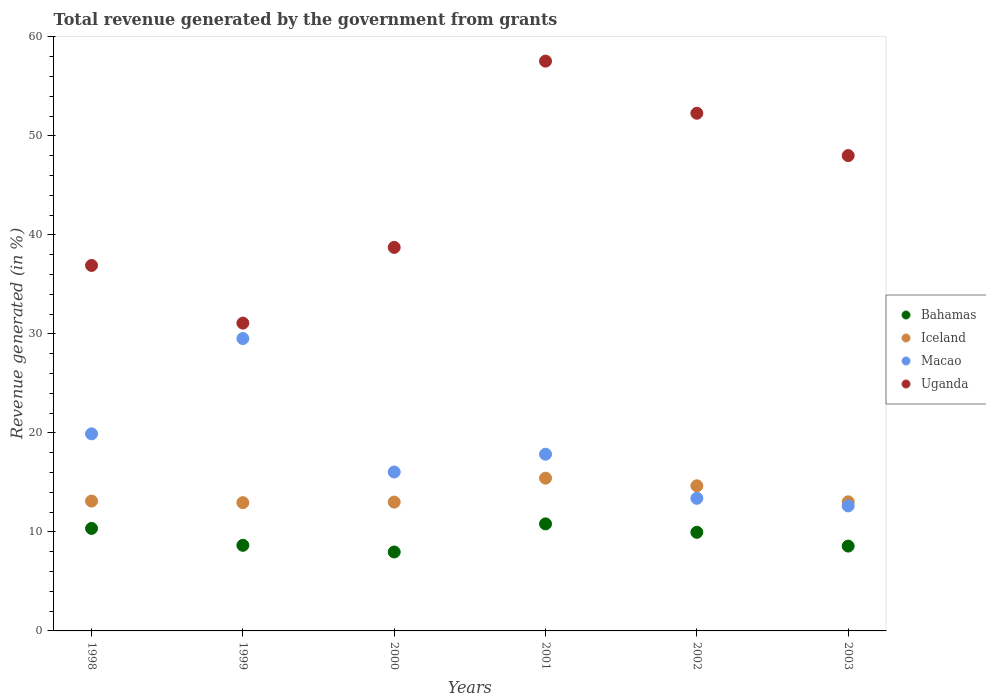How many different coloured dotlines are there?
Keep it short and to the point. 4. What is the total revenue generated in Bahamas in 1999?
Give a very brief answer. 8.64. Across all years, what is the maximum total revenue generated in Iceland?
Ensure brevity in your answer.  15.43. Across all years, what is the minimum total revenue generated in Iceland?
Keep it short and to the point. 12.95. In which year was the total revenue generated in Bahamas maximum?
Your answer should be very brief. 2001. In which year was the total revenue generated in Iceland minimum?
Your response must be concise. 1999. What is the total total revenue generated in Uganda in the graph?
Ensure brevity in your answer.  264.56. What is the difference between the total revenue generated in Iceland in 1999 and that in 2002?
Ensure brevity in your answer.  -1.7. What is the difference between the total revenue generated in Bahamas in 1998 and the total revenue generated in Macao in 2003?
Give a very brief answer. -2.27. What is the average total revenue generated in Iceland per year?
Offer a very short reply. 13.7. In the year 2001, what is the difference between the total revenue generated in Uganda and total revenue generated in Macao?
Make the answer very short. 39.7. What is the ratio of the total revenue generated in Iceland in 1999 to that in 2001?
Provide a short and direct response. 0.84. What is the difference between the highest and the second highest total revenue generated in Uganda?
Provide a succinct answer. 5.26. What is the difference between the highest and the lowest total revenue generated in Bahamas?
Ensure brevity in your answer.  2.84. Is the sum of the total revenue generated in Macao in 1999 and 2002 greater than the maximum total revenue generated in Iceland across all years?
Offer a very short reply. Yes. Is it the case that in every year, the sum of the total revenue generated in Macao and total revenue generated in Uganda  is greater than the total revenue generated in Bahamas?
Offer a very short reply. Yes. Is the total revenue generated in Bahamas strictly greater than the total revenue generated in Iceland over the years?
Ensure brevity in your answer.  No. Is the total revenue generated in Uganda strictly less than the total revenue generated in Macao over the years?
Offer a terse response. No. How many years are there in the graph?
Ensure brevity in your answer.  6. Does the graph contain any zero values?
Give a very brief answer. No. Does the graph contain grids?
Your response must be concise. No. How many legend labels are there?
Offer a terse response. 4. What is the title of the graph?
Make the answer very short. Total revenue generated by the government from grants. What is the label or title of the X-axis?
Your response must be concise. Years. What is the label or title of the Y-axis?
Keep it short and to the point. Revenue generated (in %). What is the Revenue generated (in %) in Bahamas in 1998?
Provide a short and direct response. 10.35. What is the Revenue generated (in %) of Iceland in 1998?
Make the answer very short. 13.11. What is the Revenue generated (in %) in Macao in 1998?
Offer a terse response. 19.9. What is the Revenue generated (in %) of Uganda in 1998?
Your answer should be very brief. 36.91. What is the Revenue generated (in %) in Bahamas in 1999?
Provide a short and direct response. 8.64. What is the Revenue generated (in %) in Iceland in 1999?
Offer a terse response. 12.95. What is the Revenue generated (in %) of Macao in 1999?
Offer a very short reply. 29.53. What is the Revenue generated (in %) of Uganda in 1999?
Provide a short and direct response. 31.09. What is the Revenue generated (in %) of Bahamas in 2000?
Your response must be concise. 7.97. What is the Revenue generated (in %) in Iceland in 2000?
Keep it short and to the point. 13.01. What is the Revenue generated (in %) of Macao in 2000?
Provide a succinct answer. 16.05. What is the Revenue generated (in %) of Uganda in 2000?
Your answer should be very brief. 38.73. What is the Revenue generated (in %) of Bahamas in 2001?
Make the answer very short. 10.81. What is the Revenue generated (in %) in Iceland in 2001?
Your answer should be very brief. 15.43. What is the Revenue generated (in %) of Macao in 2001?
Give a very brief answer. 17.85. What is the Revenue generated (in %) of Uganda in 2001?
Offer a terse response. 57.55. What is the Revenue generated (in %) in Bahamas in 2002?
Your answer should be compact. 9.96. What is the Revenue generated (in %) of Iceland in 2002?
Your response must be concise. 14.66. What is the Revenue generated (in %) of Macao in 2002?
Your response must be concise. 13.39. What is the Revenue generated (in %) of Uganda in 2002?
Offer a terse response. 52.28. What is the Revenue generated (in %) of Bahamas in 2003?
Provide a succinct answer. 8.57. What is the Revenue generated (in %) in Iceland in 2003?
Your response must be concise. 13.04. What is the Revenue generated (in %) of Macao in 2003?
Your answer should be compact. 12.62. What is the Revenue generated (in %) in Uganda in 2003?
Provide a succinct answer. 48.01. Across all years, what is the maximum Revenue generated (in %) in Bahamas?
Provide a succinct answer. 10.81. Across all years, what is the maximum Revenue generated (in %) in Iceland?
Your answer should be compact. 15.43. Across all years, what is the maximum Revenue generated (in %) in Macao?
Offer a very short reply. 29.53. Across all years, what is the maximum Revenue generated (in %) in Uganda?
Ensure brevity in your answer.  57.55. Across all years, what is the minimum Revenue generated (in %) of Bahamas?
Provide a succinct answer. 7.97. Across all years, what is the minimum Revenue generated (in %) of Iceland?
Offer a very short reply. 12.95. Across all years, what is the minimum Revenue generated (in %) of Macao?
Ensure brevity in your answer.  12.62. Across all years, what is the minimum Revenue generated (in %) of Uganda?
Offer a very short reply. 31.09. What is the total Revenue generated (in %) in Bahamas in the graph?
Keep it short and to the point. 56.3. What is the total Revenue generated (in %) in Iceland in the graph?
Your answer should be compact. 82.2. What is the total Revenue generated (in %) of Macao in the graph?
Give a very brief answer. 109.34. What is the total Revenue generated (in %) of Uganda in the graph?
Make the answer very short. 264.56. What is the difference between the Revenue generated (in %) of Bahamas in 1998 and that in 1999?
Offer a very short reply. 1.71. What is the difference between the Revenue generated (in %) in Iceland in 1998 and that in 1999?
Your response must be concise. 0.16. What is the difference between the Revenue generated (in %) of Macao in 1998 and that in 1999?
Your answer should be very brief. -9.63. What is the difference between the Revenue generated (in %) in Uganda in 1998 and that in 1999?
Provide a succinct answer. 5.82. What is the difference between the Revenue generated (in %) in Bahamas in 1998 and that in 2000?
Keep it short and to the point. 2.38. What is the difference between the Revenue generated (in %) in Iceland in 1998 and that in 2000?
Keep it short and to the point. 0.1. What is the difference between the Revenue generated (in %) in Macao in 1998 and that in 2000?
Give a very brief answer. 3.85. What is the difference between the Revenue generated (in %) of Uganda in 1998 and that in 2000?
Ensure brevity in your answer.  -1.82. What is the difference between the Revenue generated (in %) of Bahamas in 1998 and that in 2001?
Offer a terse response. -0.46. What is the difference between the Revenue generated (in %) of Iceland in 1998 and that in 2001?
Offer a terse response. -2.31. What is the difference between the Revenue generated (in %) of Macao in 1998 and that in 2001?
Ensure brevity in your answer.  2.06. What is the difference between the Revenue generated (in %) of Uganda in 1998 and that in 2001?
Keep it short and to the point. -20.64. What is the difference between the Revenue generated (in %) in Bahamas in 1998 and that in 2002?
Provide a succinct answer. 0.39. What is the difference between the Revenue generated (in %) of Iceland in 1998 and that in 2002?
Keep it short and to the point. -1.54. What is the difference between the Revenue generated (in %) in Macao in 1998 and that in 2002?
Your response must be concise. 6.51. What is the difference between the Revenue generated (in %) of Uganda in 1998 and that in 2002?
Make the answer very short. -15.37. What is the difference between the Revenue generated (in %) of Bahamas in 1998 and that in 2003?
Offer a very short reply. 1.78. What is the difference between the Revenue generated (in %) of Iceland in 1998 and that in 2003?
Offer a very short reply. 0.08. What is the difference between the Revenue generated (in %) of Macao in 1998 and that in 2003?
Make the answer very short. 7.28. What is the difference between the Revenue generated (in %) of Uganda in 1998 and that in 2003?
Ensure brevity in your answer.  -11.09. What is the difference between the Revenue generated (in %) in Bahamas in 1999 and that in 2000?
Give a very brief answer. 0.67. What is the difference between the Revenue generated (in %) of Iceland in 1999 and that in 2000?
Ensure brevity in your answer.  -0.06. What is the difference between the Revenue generated (in %) of Macao in 1999 and that in 2000?
Keep it short and to the point. 13.48. What is the difference between the Revenue generated (in %) of Uganda in 1999 and that in 2000?
Your answer should be very brief. -7.65. What is the difference between the Revenue generated (in %) of Bahamas in 1999 and that in 2001?
Your answer should be very brief. -2.17. What is the difference between the Revenue generated (in %) in Iceland in 1999 and that in 2001?
Provide a short and direct response. -2.47. What is the difference between the Revenue generated (in %) of Macao in 1999 and that in 2001?
Keep it short and to the point. 11.68. What is the difference between the Revenue generated (in %) in Uganda in 1999 and that in 2001?
Provide a short and direct response. -26.46. What is the difference between the Revenue generated (in %) of Bahamas in 1999 and that in 2002?
Your answer should be compact. -1.31. What is the difference between the Revenue generated (in %) of Iceland in 1999 and that in 2002?
Offer a very short reply. -1.7. What is the difference between the Revenue generated (in %) in Macao in 1999 and that in 2002?
Your response must be concise. 16.14. What is the difference between the Revenue generated (in %) of Uganda in 1999 and that in 2002?
Your answer should be compact. -21.19. What is the difference between the Revenue generated (in %) of Bahamas in 1999 and that in 2003?
Provide a short and direct response. 0.08. What is the difference between the Revenue generated (in %) in Iceland in 1999 and that in 2003?
Offer a very short reply. -0.08. What is the difference between the Revenue generated (in %) in Macao in 1999 and that in 2003?
Offer a very short reply. 16.91. What is the difference between the Revenue generated (in %) in Uganda in 1999 and that in 2003?
Ensure brevity in your answer.  -16.92. What is the difference between the Revenue generated (in %) of Bahamas in 2000 and that in 2001?
Keep it short and to the point. -2.84. What is the difference between the Revenue generated (in %) of Iceland in 2000 and that in 2001?
Provide a short and direct response. -2.42. What is the difference between the Revenue generated (in %) of Macao in 2000 and that in 2001?
Make the answer very short. -1.8. What is the difference between the Revenue generated (in %) of Uganda in 2000 and that in 2001?
Offer a terse response. -18.81. What is the difference between the Revenue generated (in %) in Bahamas in 2000 and that in 2002?
Your response must be concise. -1.99. What is the difference between the Revenue generated (in %) in Iceland in 2000 and that in 2002?
Provide a succinct answer. -1.64. What is the difference between the Revenue generated (in %) in Macao in 2000 and that in 2002?
Provide a short and direct response. 2.66. What is the difference between the Revenue generated (in %) of Uganda in 2000 and that in 2002?
Ensure brevity in your answer.  -13.55. What is the difference between the Revenue generated (in %) of Bahamas in 2000 and that in 2003?
Offer a very short reply. -0.6. What is the difference between the Revenue generated (in %) of Iceland in 2000 and that in 2003?
Keep it short and to the point. -0.03. What is the difference between the Revenue generated (in %) in Macao in 2000 and that in 2003?
Your answer should be compact. 3.42. What is the difference between the Revenue generated (in %) of Uganda in 2000 and that in 2003?
Your answer should be very brief. -9.27. What is the difference between the Revenue generated (in %) in Bahamas in 2001 and that in 2002?
Your answer should be compact. 0.85. What is the difference between the Revenue generated (in %) in Iceland in 2001 and that in 2002?
Offer a very short reply. 0.77. What is the difference between the Revenue generated (in %) of Macao in 2001 and that in 2002?
Ensure brevity in your answer.  4.45. What is the difference between the Revenue generated (in %) in Uganda in 2001 and that in 2002?
Offer a terse response. 5.26. What is the difference between the Revenue generated (in %) in Bahamas in 2001 and that in 2003?
Provide a succinct answer. 2.24. What is the difference between the Revenue generated (in %) of Iceland in 2001 and that in 2003?
Offer a very short reply. 2.39. What is the difference between the Revenue generated (in %) of Macao in 2001 and that in 2003?
Provide a short and direct response. 5.22. What is the difference between the Revenue generated (in %) of Uganda in 2001 and that in 2003?
Give a very brief answer. 9.54. What is the difference between the Revenue generated (in %) of Bahamas in 2002 and that in 2003?
Ensure brevity in your answer.  1.39. What is the difference between the Revenue generated (in %) of Iceland in 2002 and that in 2003?
Make the answer very short. 1.62. What is the difference between the Revenue generated (in %) of Macao in 2002 and that in 2003?
Provide a succinct answer. 0.77. What is the difference between the Revenue generated (in %) of Uganda in 2002 and that in 2003?
Ensure brevity in your answer.  4.28. What is the difference between the Revenue generated (in %) in Bahamas in 1998 and the Revenue generated (in %) in Iceland in 1999?
Your response must be concise. -2.6. What is the difference between the Revenue generated (in %) in Bahamas in 1998 and the Revenue generated (in %) in Macao in 1999?
Your answer should be compact. -19.18. What is the difference between the Revenue generated (in %) of Bahamas in 1998 and the Revenue generated (in %) of Uganda in 1999?
Ensure brevity in your answer.  -20.73. What is the difference between the Revenue generated (in %) in Iceland in 1998 and the Revenue generated (in %) in Macao in 1999?
Provide a succinct answer. -16.42. What is the difference between the Revenue generated (in %) in Iceland in 1998 and the Revenue generated (in %) in Uganda in 1999?
Your response must be concise. -17.97. What is the difference between the Revenue generated (in %) of Macao in 1998 and the Revenue generated (in %) of Uganda in 1999?
Offer a terse response. -11.19. What is the difference between the Revenue generated (in %) in Bahamas in 1998 and the Revenue generated (in %) in Iceland in 2000?
Your answer should be compact. -2.66. What is the difference between the Revenue generated (in %) of Bahamas in 1998 and the Revenue generated (in %) of Macao in 2000?
Offer a terse response. -5.7. What is the difference between the Revenue generated (in %) in Bahamas in 1998 and the Revenue generated (in %) in Uganda in 2000?
Provide a succinct answer. -28.38. What is the difference between the Revenue generated (in %) of Iceland in 1998 and the Revenue generated (in %) of Macao in 2000?
Offer a terse response. -2.94. What is the difference between the Revenue generated (in %) in Iceland in 1998 and the Revenue generated (in %) in Uganda in 2000?
Give a very brief answer. -25.62. What is the difference between the Revenue generated (in %) of Macao in 1998 and the Revenue generated (in %) of Uganda in 2000?
Make the answer very short. -18.83. What is the difference between the Revenue generated (in %) of Bahamas in 1998 and the Revenue generated (in %) of Iceland in 2001?
Your answer should be compact. -5.08. What is the difference between the Revenue generated (in %) of Bahamas in 1998 and the Revenue generated (in %) of Macao in 2001?
Provide a short and direct response. -7.49. What is the difference between the Revenue generated (in %) in Bahamas in 1998 and the Revenue generated (in %) in Uganda in 2001?
Your answer should be very brief. -47.19. What is the difference between the Revenue generated (in %) of Iceland in 1998 and the Revenue generated (in %) of Macao in 2001?
Offer a very short reply. -4.73. What is the difference between the Revenue generated (in %) of Iceland in 1998 and the Revenue generated (in %) of Uganda in 2001?
Offer a terse response. -44.43. What is the difference between the Revenue generated (in %) of Macao in 1998 and the Revenue generated (in %) of Uganda in 2001?
Offer a terse response. -37.65. What is the difference between the Revenue generated (in %) in Bahamas in 1998 and the Revenue generated (in %) in Iceland in 2002?
Provide a short and direct response. -4.3. What is the difference between the Revenue generated (in %) in Bahamas in 1998 and the Revenue generated (in %) in Macao in 2002?
Provide a succinct answer. -3.04. What is the difference between the Revenue generated (in %) in Bahamas in 1998 and the Revenue generated (in %) in Uganda in 2002?
Make the answer very short. -41.93. What is the difference between the Revenue generated (in %) in Iceland in 1998 and the Revenue generated (in %) in Macao in 2002?
Your answer should be very brief. -0.28. What is the difference between the Revenue generated (in %) in Iceland in 1998 and the Revenue generated (in %) in Uganda in 2002?
Your answer should be compact. -39.17. What is the difference between the Revenue generated (in %) in Macao in 1998 and the Revenue generated (in %) in Uganda in 2002?
Provide a short and direct response. -32.38. What is the difference between the Revenue generated (in %) in Bahamas in 1998 and the Revenue generated (in %) in Iceland in 2003?
Provide a succinct answer. -2.69. What is the difference between the Revenue generated (in %) in Bahamas in 1998 and the Revenue generated (in %) in Macao in 2003?
Offer a terse response. -2.27. What is the difference between the Revenue generated (in %) in Bahamas in 1998 and the Revenue generated (in %) in Uganda in 2003?
Provide a short and direct response. -37.65. What is the difference between the Revenue generated (in %) of Iceland in 1998 and the Revenue generated (in %) of Macao in 2003?
Your response must be concise. 0.49. What is the difference between the Revenue generated (in %) in Iceland in 1998 and the Revenue generated (in %) in Uganda in 2003?
Your answer should be very brief. -34.89. What is the difference between the Revenue generated (in %) in Macao in 1998 and the Revenue generated (in %) in Uganda in 2003?
Your answer should be compact. -28.1. What is the difference between the Revenue generated (in %) in Bahamas in 1999 and the Revenue generated (in %) in Iceland in 2000?
Give a very brief answer. -4.37. What is the difference between the Revenue generated (in %) in Bahamas in 1999 and the Revenue generated (in %) in Macao in 2000?
Provide a succinct answer. -7.4. What is the difference between the Revenue generated (in %) of Bahamas in 1999 and the Revenue generated (in %) of Uganda in 2000?
Give a very brief answer. -30.09. What is the difference between the Revenue generated (in %) in Iceland in 1999 and the Revenue generated (in %) in Macao in 2000?
Keep it short and to the point. -3.09. What is the difference between the Revenue generated (in %) in Iceland in 1999 and the Revenue generated (in %) in Uganda in 2000?
Offer a terse response. -25.78. What is the difference between the Revenue generated (in %) of Macao in 1999 and the Revenue generated (in %) of Uganda in 2000?
Provide a succinct answer. -9.2. What is the difference between the Revenue generated (in %) in Bahamas in 1999 and the Revenue generated (in %) in Iceland in 2001?
Make the answer very short. -6.78. What is the difference between the Revenue generated (in %) in Bahamas in 1999 and the Revenue generated (in %) in Macao in 2001?
Your response must be concise. -9.2. What is the difference between the Revenue generated (in %) of Bahamas in 1999 and the Revenue generated (in %) of Uganda in 2001?
Ensure brevity in your answer.  -48.9. What is the difference between the Revenue generated (in %) in Iceland in 1999 and the Revenue generated (in %) in Macao in 2001?
Make the answer very short. -4.89. What is the difference between the Revenue generated (in %) in Iceland in 1999 and the Revenue generated (in %) in Uganda in 2001?
Provide a short and direct response. -44.59. What is the difference between the Revenue generated (in %) in Macao in 1999 and the Revenue generated (in %) in Uganda in 2001?
Your response must be concise. -28.02. What is the difference between the Revenue generated (in %) in Bahamas in 1999 and the Revenue generated (in %) in Iceland in 2002?
Your answer should be very brief. -6.01. What is the difference between the Revenue generated (in %) in Bahamas in 1999 and the Revenue generated (in %) in Macao in 2002?
Your answer should be compact. -4.75. What is the difference between the Revenue generated (in %) in Bahamas in 1999 and the Revenue generated (in %) in Uganda in 2002?
Ensure brevity in your answer.  -43.64. What is the difference between the Revenue generated (in %) in Iceland in 1999 and the Revenue generated (in %) in Macao in 2002?
Give a very brief answer. -0.44. What is the difference between the Revenue generated (in %) in Iceland in 1999 and the Revenue generated (in %) in Uganda in 2002?
Offer a very short reply. -39.33. What is the difference between the Revenue generated (in %) in Macao in 1999 and the Revenue generated (in %) in Uganda in 2002?
Keep it short and to the point. -22.75. What is the difference between the Revenue generated (in %) in Bahamas in 1999 and the Revenue generated (in %) in Iceland in 2003?
Your answer should be compact. -4.39. What is the difference between the Revenue generated (in %) of Bahamas in 1999 and the Revenue generated (in %) of Macao in 2003?
Make the answer very short. -3.98. What is the difference between the Revenue generated (in %) of Bahamas in 1999 and the Revenue generated (in %) of Uganda in 2003?
Ensure brevity in your answer.  -39.36. What is the difference between the Revenue generated (in %) of Iceland in 1999 and the Revenue generated (in %) of Macao in 2003?
Provide a succinct answer. 0.33. What is the difference between the Revenue generated (in %) of Iceland in 1999 and the Revenue generated (in %) of Uganda in 2003?
Provide a succinct answer. -35.05. What is the difference between the Revenue generated (in %) in Macao in 1999 and the Revenue generated (in %) in Uganda in 2003?
Give a very brief answer. -18.48. What is the difference between the Revenue generated (in %) in Bahamas in 2000 and the Revenue generated (in %) in Iceland in 2001?
Your answer should be very brief. -7.46. What is the difference between the Revenue generated (in %) of Bahamas in 2000 and the Revenue generated (in %) of Macao in 2001?
Your answer should be compact. -9.87. What is the difference between the Revenue generated (in %) in Bahamas in 2000 and the Revenue generated (in %) in Uganda in 2001?
Offer a terse response. -49.58. What is the difference between the Revenue generated (in %) of Iceland in 2000 and the Revenue generated (in %) of Macao in 2001?
Offer a very short reply. -4.83. What is the difference between the Revenue generated (in %) of Iceland in 2000 and the Revenue generated (in %) of Uganda in 2001?
Make the answer very short. -44.53. What is the difference between the Revenue generated (in %) in Macao in 2000 and the Revenue generated (in %) in Uganda in 2001?
Give a very brief answer. -41.5. What is the difference between the Revenue generated (in %) of Bahamas in 2000 and the Revenue generated (in %) of Iceland in 2002?
Keep it short and to the point. -6.68. What is the difference between the Revenue generated (in %) in Bahamas in 2000 and the Revenue generated (in %) in Macao in 2002?
Your answer should be compact. -5.42. What is the difference between the Revenue generated (in %) of Bahamas in 2000 and the Revenue generated (in %) of Uganda in 2002?
Provide a short and direct response. -44.31. What is the difference between the Revenue generated (in %) of Iceland in 2000 and the Revenue generated (in %) of Macao in 2002?
Provide a short and direct response. -0.38. What is the difference between the Revenue generated (in %) in Iceland in 2000 and the Revenue generated (in %) in Uganda in 2002?
Provide a succinct answer. -39.27. What is the difference between the Revenue generated (in %) in Macao in 2000 and the Revenue generated (in %) in Uganda in 2002?
Keep it short and to the point. -36.23. What is the difference between the Revenue generated (in %) in Bahamas in 2000 and the Revenue generated (in %) in Iceland in 2003?
Make the answer very short. -5.07. What is the difference between the Revenue generated (in %) in Bahamas in 2000 and the Revenue generated (in %) in Macao in 2003?
Give a very brief answer. -4.65. What is the difference between the Revenue generated (in %) of Bahamas in 2000 and the Revenue generated (in %) of Uganda in 2003?
Offer a very short reply. -40.03. What is the difference between the Revenue generated (in %) in Iceland in 2000 and the Revenue generated (in %) in Macao in 2003?
Your answer should be compact. 0.39. What is the difference between the Revenue generated (in %) in Iceland in 2000 and the Revenue generated (in %) in Uganda in 2003?
Keep it short and to the point. -34.99. What is the difference between the Revenue generated (in %) in Macao in 2000 and the Revenue generated (in %) in Uganda in 2003?
Your answer should be very brief. -31.96. What is the difference between the Revenue generated (in %) in Bahamas in 2001 and the Revenue generated (in %) in Iceland in 2002?
Offer a terse response. -3.85. What is the difference between the Revenue generated (in %) in Bahamas in 2001 and the Revenue generated (in %) in Macao in 2002?
Keep it short and to the point. -2.58. What is the difference between the Revenue generated (in %) in Bahamas in 2001 and the Revenue generated (in %) in Uganda in 2002?
Make the answer very short. -41.47. What is the difference between the Revenue generated (in %) in Iceland in 2001 and the Revenue generated (in %) in Macao in 2002?
Your answer should be compact. 2.04. What is the difference between the Revenue generated (in %) in Iceland in 2001 and the Revenue generated (in %) in Uganda in 2002?
Your response must be concise. -36.85. What is the difference between the Revenue generated (in %) of Macao in 2001 and the Revenue generated (in %) of Uganda in 2002?
Give a very brief answer. -34.44. What is the difference between the Revenue generated (in %) in Bahamas in 2001 and the Revenue generated (in %) in Iceland in 2003?
Keep it short and to the point. -2.23. What is the difference between the Revenue generated (in %) of Bahamas in 2001 and the Revenue generated (in %) of Macao in 2003?
Give a very brief answer. -1.81. What is the difference between the Revenue generated (in %) in Bahamas in 2001 and the Revenue generated (in %) in Uganda in 2003?
Provide a short and direct response. -37.2. What is the difference between the Revenue generated (in %) of Iceland in 2001 and the Revenue generated (in %) of Macao in 2003?
Make the answer very short. 2.8. What is the difference between the Revenue generated (in %) of Iceland in 2001 and the Revenue generated (in %) of Uganda in 2003?
Your answer should be compact. -32.58. What is the difference between the Revenue generated (in %) in Macao in 2001 and the Revenue generated (in %) in Uganda in 2003?
Provide a succinct answer. -30.16. What is the difference between the Revenue generated (in %) in Bahamas in 2002 and the Revenue generated (in %) in Iceland in 2003?
Your answer should be compact. -3.08. What is the difference between the Revenue generated (in %) of Bahamas in 2002 and the Revenue generated (in %) of Macao in 2003?
Offer a terse response. -2.67. What is the difference between the Revenue generated (in %) in Bahamas in 2002 and the Revenue generated (in %) in Uganda in 2003?
Your response must be concise. -38.05. What is the difference between the Revenue generated (in %) in Iceland in 2002 and the Revenue generated (in %) in Macao in 2003?
Provide a short and direct response. 2.03. What is the difference between the Revenue generated (in %) of Iceland in 2002 and the Revenue generated (in %) of Uganda in 2003?
Offer a very short reply. -33.35. What is the difference between the Revenue generated (in %) in Macao in 2002 and the Revenue generated (in %) in Uganda in 2003?
Give a very brief answer. -34.61. What is the average Revenue generated (in %) in Bahamas per year?
Provide a short and direct response. 9.38. What is the average Revenue generated (in %) in Iceland per year?
Your answer should be very brief. 13.7. What is the average Revenue generated (in %) of Macao per year?
Ensure brevity in your answer.  18.22. What is the average Revenue generated (in %) in Uganda per year?
Keep it short and to the point. 44.09. In the year 1998, what is the difference between the Revenue generated (in %) in Bahamas and Revenue generated (in %) in Iceland?
Give a very brief answer. -2.76. In the year 1998, what is the difference between the Revenue generated (in %) of Bahamas and Revenue generated (in %) of Macao?
Provide a succinct answer. -9.55. In the year 1998, what is the difference between the Revenue generated (in %) of Bahamas and Revenue generated (in %) of Uganda?
Your answer should be very brief. -26.56. In the year 1998, what is the difference between the Revenue generated (in %) in Iceland and Revenue generated (in %) in Macao?
Keep it short and to the point. -6.79. In the year 1998, what is the difference between the Revenue generated (in %) of Iceland and Revenue generated (in %) of Uganda?
Your answer should be very brief. -23.8. In the year 1998, what is the difference between the Revenue generated (in %) in Macao and Revenue generated (in %) in Uganda?
Your response must be concise. -17.01. In the year 1999, what is the difference between the Revenue generated (in %) in Bahamas and Revenue generated (in %) in Iceland?
Offer a terse response. -4.31. In the year 1999, what is the difference between the Revenue generated (in %) of Bahamas and Revenue generated (in %) of Macao?
Offer a terse response. -20.88. In the year 1999, what is the difference between the Revenue generated (in %) of Bahamas and Revenue generated (in %) of Uganda?
Make the answer very short. -22.44. In the year 1999, what is the difference between the Revenue generated (in %) of Iceland and Revenue generated (in %) of Macao?
Offer a very short reply. -16.57. In the year 1999, what is the difference between the Revenue generated (in %) of Iceland and Revenue generated (in %) of Uganda?
Give a very brief answer. -18.13. In the year 1999, what is the difference between the Revenue generated (in %) in Macao and Revenue generated (in %) in Uganda?
Provide a succinct answer. -1.56. In the year 2000, what is the difference between the Revenue generated (in %) of Bahamas and Revenue generated (in %) of Iceland?
Give a very brief answer. -5.04. In the year 2000, what is the difference between the Revenue generated (in %) in Bahamas and Revenue generated (in %) in Macao?
Make the answer very short. -8.08. In the year 2000, what is the difference between the Revenue generated (in %) in Bahamas and Revenue generated (in %) in Uganda?
Provide a short and direct response. -30.76. In the year 2000, what is the difference between the Revenue generated (in %) in Iceland and Revenue generated (in %) in Macao?
Keep it short and to the point. -3.04. In the year 2000, what is the difference between the Revenue generated (in %) of Iceland and Revenue generated (in %) of Uganda?
Offer a terse response. -25.72. In the year 2000, what is the difference between the Revenue generated (in %) of Macao and Revenue generated (in %) of Uganda?
Provide a succinct answer. -22.68. In the year 2001, what is the difference between the Revenue generated (in %) in Bahamas and Revenue generated (in %) in Iceland?
Ensure brevity in your answer.  -4.62. In the year 2001, what is the difference between the Revenue generated (in %) of Bahamas and Revenue generated (in %) of Macao?
Provide a short and direct response. -7.04. In the year 2001, what is the difference between the Revenue generated (in %) in Bahamas and Revenue generated (in %) in Uganda?
Give a very brief answer. -46.74. In the year 2001, what is the difference between the Revenue generated (in %) in Iceland and Revenue generated (in %) in Macao?
Your answer should be very brief. -2.42. In the year 2001, what is the difference between the Revenue generated (in %) in Iceland and Revenue generated (in %) in Uganda?
Provide a succinct answer. -42.12. In the year 2001, what is the difference between the Revenue generated (in %) in Macao and Revenue generated (in %) in Uganda?
Make the answer very short. -39.7. In the year 2002, what is the difference between the Revenue generated (in %) in Bahamas and Revenue generated (in %) in Iceland?
Your answer should be very brief. -4.7. In the year 2002, what is the difference between the Revenue generated (in %) of Bahamas and Revenue generated (in %) of Macao?
Ensure brevity in your answer.  -3.43. In the year 2002, what is the difference between the Revenue generated (in %) in Bahamas and Revenue generated (in %) in Uganda?
Your answer should be compact. -42.32. In the year 2002, what is the difference between the Revenue generated (in %) of Iceland and Revenue generated (in %) of Macao?
Your answer should be compact. 1.26. In the year 2002, what is the difference between the Revenue generated (in %) in Iceland and Revenue generated (in %) in Uganda?
Your answer should be very brief. -37.63. In the year 2002, what is the difference between the Revenue generated (in %) in Macao and Revenue generated (in %) in Uganda?
Ensure brevity in your answer.  -38.89. In the year 2003, what is the difference between the Revenue generated (in %) of Bahamas and Revenue generated (in %) of Iceland?
Make the answer very short. -4.47. In the year 2003, what is the difference between the Revenue generated (in %) of Bahamas and Revenue generated (in %) of Macao?
Offer a very short reply. -4.06. In the year 2003, what is the difference between the Revenue generated (in %) in Bahamas and Revenue generated (in %) in Uganda?
Provide a succinct answer. -39.44. In the year 2003, what is the difference between the Revenue generated (in %) of Iceland and Revenue generated (in %) of Macao?
Make the answer very short. 0.41. In the year 2003, what is the difference between the Revenue generated (in %) in Iceland and Revenue generated (in %) in Uganda?
Make the answer very short. -34.97. In the year 2003, what is the difference between the Revenue generated (in %) in Macao and Revenue generated (in %) in Uganda?
Your answer should be very brief. -35.38. What is the ratio of the Revenue generated (in %) in Bahamas in 1998 to that in 1999?
Provide a short and direct response. 1.2. What is the ratio of the Revenue generated (in %) of Iceland in 1998 to that in 1999?
Provide a succinct answer. 1.01. What is the ratio of the Revenue generated (in %) in Macao in 1998 to that in 1999?
Make the answer very short. 0.67. What is the ratio of the Revenue generated (in %) in Uganda in 1998 to that in 1999?
Provide a short and direct response. 1.19. What is the ratio of the Revenue generated (in %) of Bahamas in 1998 to that in 2000?
Keep it short and to the point. 1.3. What is the ratio of the Revenue generated (in %) of Iceland in 1998 to that in 2000?
Your response must be concise. 1.01. What is the ratio of the Revenue generated (in %) in Macao in 1998 to that in 2000?
Offer a terse response. 1.24. What is the ratio of the Revenue generated (in %) in Uganda in 1998 to that in 2000?
Provide a short and direct response. 0.95. What is the ratio of the Revenue generated (in %) in Bahamas in 1998 to that in 2001?
Your answer should be compact. 0.96. What is the ratio of the Revenue generated (in %) in Macao in 1998 to that in 2001?
Offer a very short reply. 1.12. What is the ratio of the Revenue generated (in %) of Uganda in 1998 to that in 2001?
Keep it short and to the point. 0.64. What is the ratio of the Revenue generated (in %) of Bahamas in 1998 to that in 2002?
Your response must be concise. 1.04. What is the ratio of the Revenue generated (in %) in Iceland in 1998 to that in 2002?
Provide a short and direct response. 0.89. What is the ratio of the Revenue generated (in %) of Macao in 1998 to that in 2002?
Offer a terse response. 1.49. What is the ratio of the Revenue generated (in %) of Uganda in 1998 to that in 2002?
Offer a very short reply. 0.71. What is the ratio of the Revenue generated (in %) in Bahamas in 1998 to that in 2003?
Provide a succinct answer. 1.21. What is the ratio of the Revenue generated (in %) of Macao in 1998 to that in 2003?
Offer a very short reply. 1.58. What is the ratio of the Revenue generated (in %) in Uganda in 1998 to that in 2003?
Your answer should be compact. 0.77. What is the ratio of the Revenue generated (in %) in Bahamas in 1999 to that in 2000?
Your response must be concise. 1.08. What is the ratio of the Revenue generated (in %) in Iceland in 1999 to that in 2000?
Offer a very short reply. 1. What is the ratio of the Revenue generated (in %) of Macao in 1999 to that in 2000?
Your answer should be very brief. 1.84. What is the ratio of the Revenue generated (in %) of Uganda in 1999 to that in 2000?
Give a very brief answer. 0.8. What is the ratio of the Revenue generated (in %) in Bahamas in 1999 to that in 2001?
Your answer should be compact. 0.8. What is the ratio of the Revenue generated (in %) in Iceland in 1999 to that in 2001?
Ensure brevity in your answer.  0.84. What is the ratio of the Revenue generated (in %) of Macao in 1999 to that in 2001?
Keep it short and to the point. 1.65. What is the ratio of the Revenue generated (in %) of Uganda in 1999 to that in 2001?
Offer a very short reply. 0.54. What is the ratio of the Revenue generated (in %) in Bahamas in 1999 to that in 2002?
Your answer should be compact. 0.87. What is the ratio of the Revenue generated (in %) in Iceland in 1999 to that in 2002?
Provide a succinct answer. 0.88. What is the ratio of the Revenue generated (in %) of Macao in 1999 to that in 2002?
Offer a terse response. 2.21. What is the ratio of the Revenue generated (in %) of Uganda in 1999 to that in 2002?
Offer a very short reply. 0.59. What is the ratio of the Revenue generated (in %) of Bahamas in 1999 to that in 2003?
Keep it short and to the point. 1.01. What is the ratio of the Revenue generated (in %) of Iceland in 1999 to that in 2003?
Your answer should be compact. 0.99. What is the ratio of the Revenue generated (in %) in Macao in 1999 to that in 2003?
Keep it short and to the point. 2.34. What is the ratio of the Revenue generated (in %) in Uganda in 1999 to that in 2003?
Your response must be concise. 0.65. What is the ratio of the Revenue generated (in %) in Bahamas in 2000 to that in 2001?
Your response must be concise. 0.74. What is the ratio of the Revenue generated (in %) of Iceland in 2000 to that in 2001?
Your answer should be very brief. 0.84. What is the ratio of the Revenue generated (in %) in Macao in 2000 to that in 2001?
Offer a terse response. 0.9. What is the ratio of the Revenue generated (in %) in Uganda in 2000 to that in 2001?
Give a very brief answer. 0.67. What is the ratio of the Revenue generated (in %) in Bahamas in 2000 to that in 2002?
Your answer should be compact. 0.8. What is the ratio of the Revenue generated (in %) of Iceland in 2000 to that in 2002?
Provide a succinct answer. 0.89. What is the ratio of the Revenue generated (in %) of Macao in 2000 to that in 2002?
Keep it short and to the point. 1.2. What is the ratio of the Revenue generated (in %) in Uganda in 2000 to that in 2002?
Keep it short and to the point. 0.74. What is the ratio of the Revenue generated (in %) of Bahamas in 2000 to that in 2003?
Offer a very short reply. 0.93. What is the ratio of the Revenue generated (in %) in Iceland in 2000 to that in 2003?
Provide a succinct answer. 1. What is the ratio of the Revenue generated (in %) in Macao in 2000 to that in 2003?
Give a very brief answer. 1.27. What is the ratio of the Revenue generated (in %) in Uganda in 2000 to that in 2003?
Provide a succinct answer. 0.81. What is the ratio of the Revenue generated (in %) of Bahamas in 2001 to that in 2002?
Offer a very short reply. 1.09. What is the ratio of the Revenue generated (in %) of Iceland in 2001 to that in 2002?
Provide a succinct answer. 1.05. What is the ratio of the Revenue generated (in %) in Macao in 2001 to that in 2002?
Offer a very short reply. 1.33. What is the ratio of the Revenue generated (in %) of Uganda in 2001 to that in 2002?
Your response must be concise. 1.1. What is the ratio of the Revenue generated (in %) of Bahamas in 2001 to that in 2003?
Your answer should be very brief. 1.26. What is the ratio of the Revenue generated (in %) of Iceland in 2001 to that in 2003?
Provide a succinct answer. 1.18. What is the ratio of the Revenue generated (in %) of Macao in 2001 to that in 2003?
Keep it short and to the point. 1.41. What is the ratio of the Revenue generated (in %) in Uganda in 2001 to that in 2003?
Ensure brevity in your answer.  1.2. What is the ratio of the Revenue generated (in %) in Bahamas in 2002 to that in 2003?
Offer a very short reply. 1.16. What is the ratio of the Revenue generated (in %) of Iceland in 2002 to that in 2003?
Your response must be concise. 1.12. What is the ratio of the Revenue generated (in %) in Macao in 2002 to that in 2003?
Offer a terse response. 1.06. What is the ratio of the Revenue generated (in %) in Uganda in 2002 to that in 2003?
Your response must be concise. 1.09. What is the difference between the highest and the second highest Revenue generated (in %) of Bahamas?
Make the answer very short. 0.46. What is the difference between the highest and the second highest Revenue generated (in %) in Iceland?
Your response must be concise. 0.77. What is the difference between the highest and the second highest Revenue generated (in %) of Macao?
Provide a short and direct response. 9.63. What is the difference between the highest and the second highest Revenue generated (in %) of Uganda?
Offer a terse response. 5.26. What is the difference between the highest and the lowest Revenue generated (in %) in Bahamas?
Your response must be concise. 2.84. What is the difference between the highest and the lowest Revenue generated (in %) of Iceland?
Keep it short and to the point. 2.47. What is the difference between the highest and the lowest Revenue generated (in %) of Macao?
Provide a short and direct response. 16.91. What is the difference between the highest and the lowest Revenue generated (in %) of Uganda?
Provide a succinct answer. 26.46. 